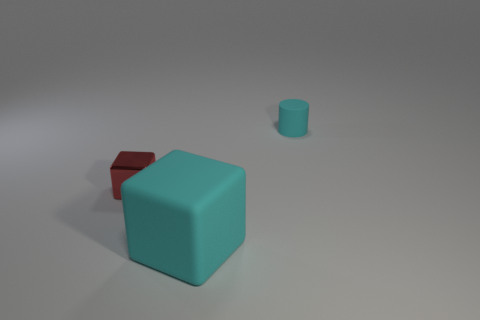Subtract all cyan blocks. How many blocks are left? 1 Add 3 small matte cylinders. How many objects exist? 6 Subtract all cubes. How many objects are left? 1 Subtract 0 gray cylinders. How many objects are left? 3 Subtract 2 blocks. How many blocks are left? 0 Subtract all red cylinders. Subtract all red spheres. How many cylinders are left? 1 Subtract all yellow balls. How many green cubes are left? 0 Subtract all small cyan things. Subtract all tiny red objects. How many objects are left? 1 Add 3 cyan matte blocks. How many cyan matte blocks are left? 4 Add 3 tiny cyan things. How many tiny cyan things exist? 4 